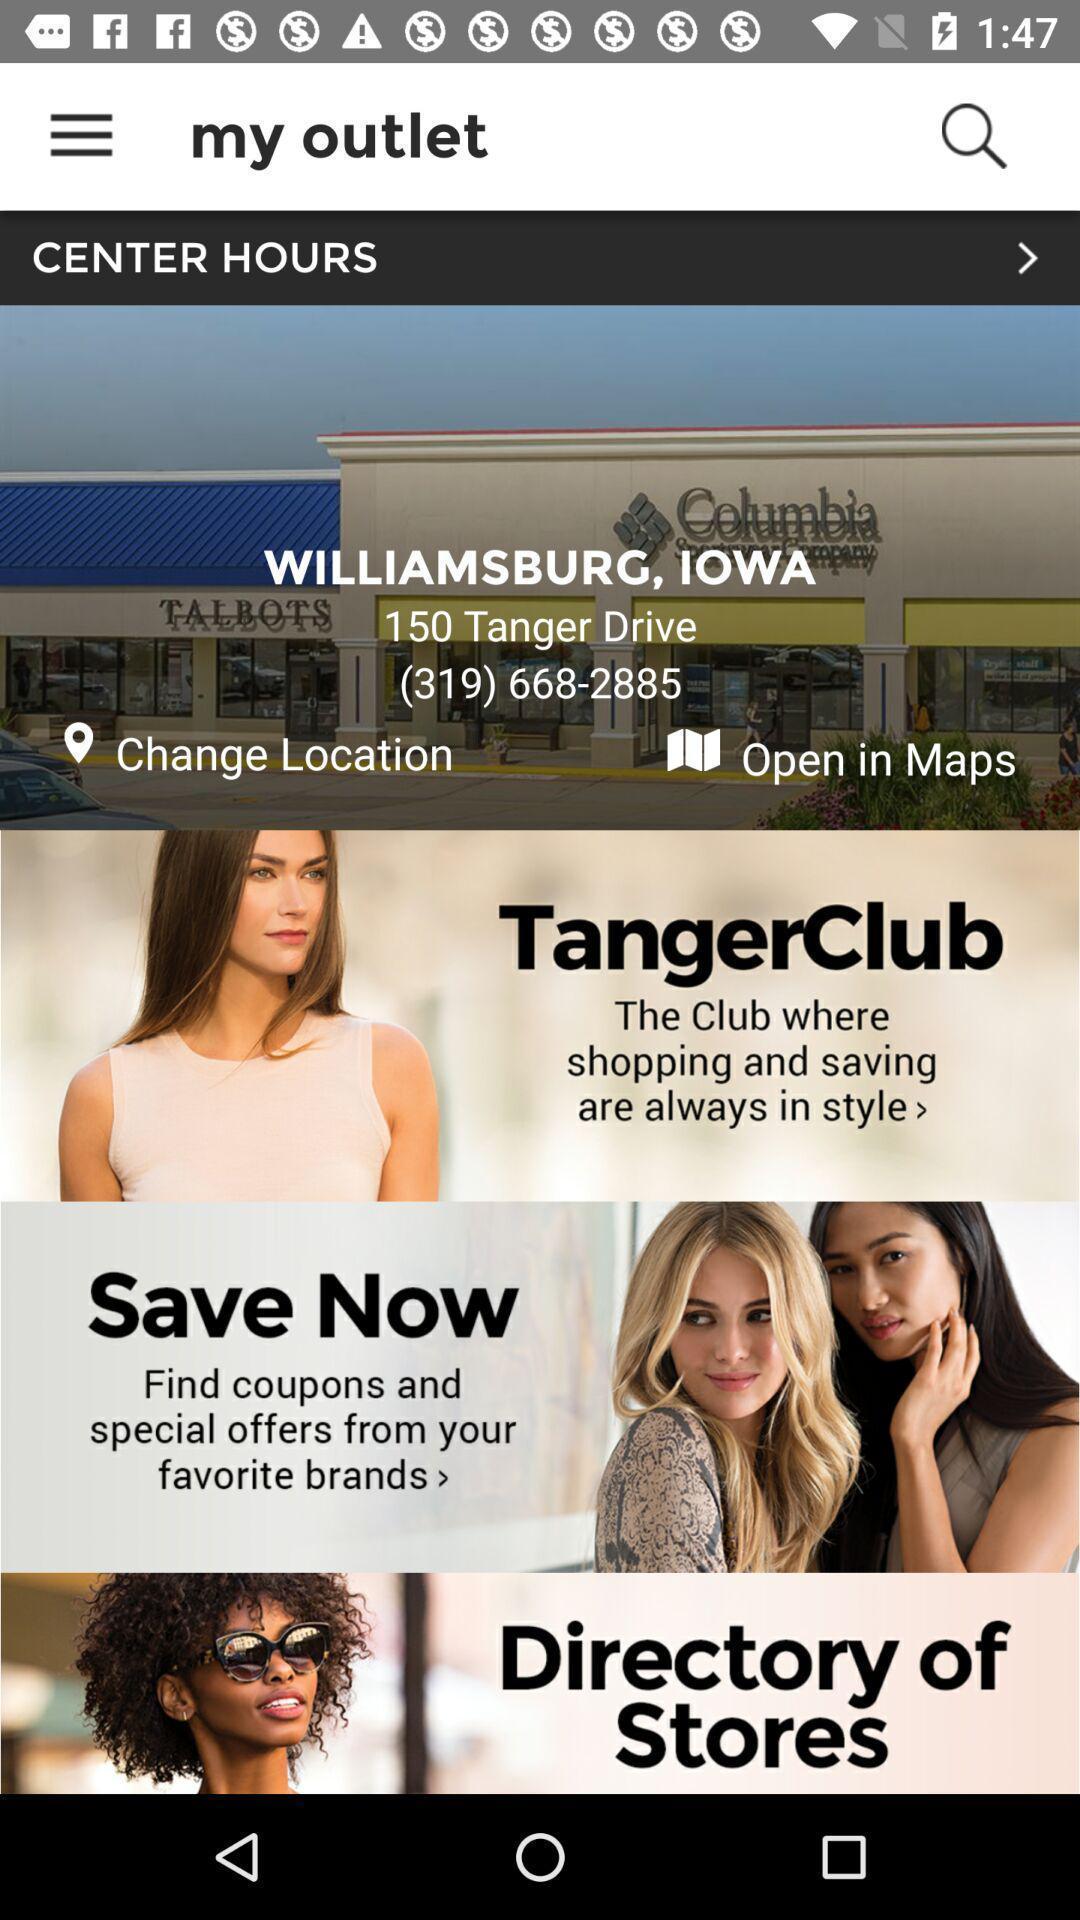Summarize the main components in this picture. Search page for searching a outlets. 